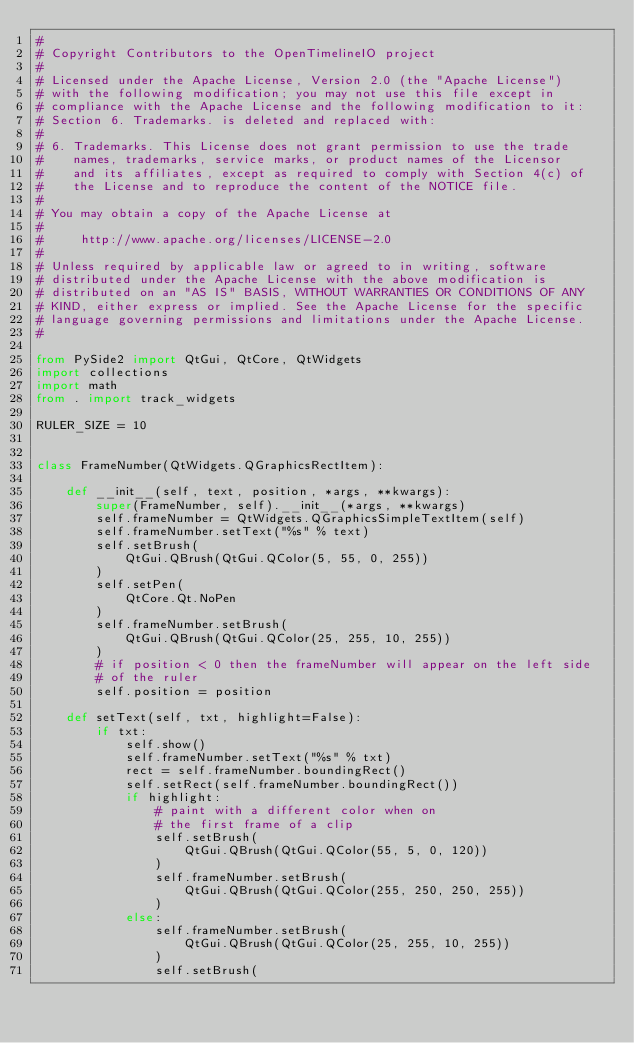<code> <loc_0><loc_0><loc_500><loc_500><_Python_>#
# Copyright Contributors to the OpenTimelineIO project
#
# Licensed under the Apache License, Version 2.0 (the "Apache License")
# with the following modification; you may not use this file except in
# compliance with the Apache License and the following modification to it:
# Section 6. Trademarks. is deleted and replaced with:
#
# 6. Trademarks. This License does not grant permission to use the trade
#    names, trademarks, service marks, or product names of the Licensor
#    and its affiliates, except as required to comply with Section 4(c) of
#    the License and to reproduce the content of the NOTICE file.
#
# You may obtain a copy of the Apache License at
#
#     http://www.apache.org/licenses/LICENSE-2.0
#
# Unless required by applicable law or agreed to in writing, software
# distributed under the Apache License with the above modification is
# distributed on an "AS IS" BASIS, WITHOUT WARRANTIES OR CONDITIONS OF ANY
# KIND, either express or implied. See the Apache License for the specific
# language governing permissions and limitations under the Apache License.
#

from PySide2 import QtGui, QtCore, QtWidgets
import collections
import math
from . import track_widgets

RULER_SIZE = 10


class FrameNumber(QtWidgets.QGraphicsRectItem):

    def __init__(self, text, position, *args, **kwargs):
        super(FrameNumber, self).__init__(*args, **kwargs)
        self.frameNumber = QtWidgets.QGraphicsSimpleTextItem(self)
        self.frameNumber.setText("%s" % text)
        self.setBrush(
            QtGui.QBrush(QtGui.QColor(5, 55, 0, 255))
        )
        self.setPen(
            QtCore.Qt.NoPen
        )
        self.frameNumber.setBrush(
            QtGui.QBrush(QtGui.QColor(25, 255, 10, 255))
        )
        # if position < 0 then the frameNumber will appear on the left side
        # of the ruler
        self.position = position

    def setText(self, txt, highlight=False):
        if txt:
            self.show()
            self.frameNumber.setText("%s" % txt)
            rect = self.frameNumber.boundingRect()
            self.setRect(self.frameNumber.boundingRect())
            if highlight:
                # paint with a different color when on
                # the first frame of a clip
                self.setBrush(
                    QtGui.QBrush(QtGui.QColor(55, 5, 0, 120))
                )
                self.frameNumber.setBrush(
                    QtGui.QBrush(QtGui.QColor(255, 250, 250, 255))
                )
            else:
                self.frameNumber.setBrush(
                    QtGui.QBrush(QtGui.QColor(25, 255, 10, 255))
                )
                self.setBrush(</code> 